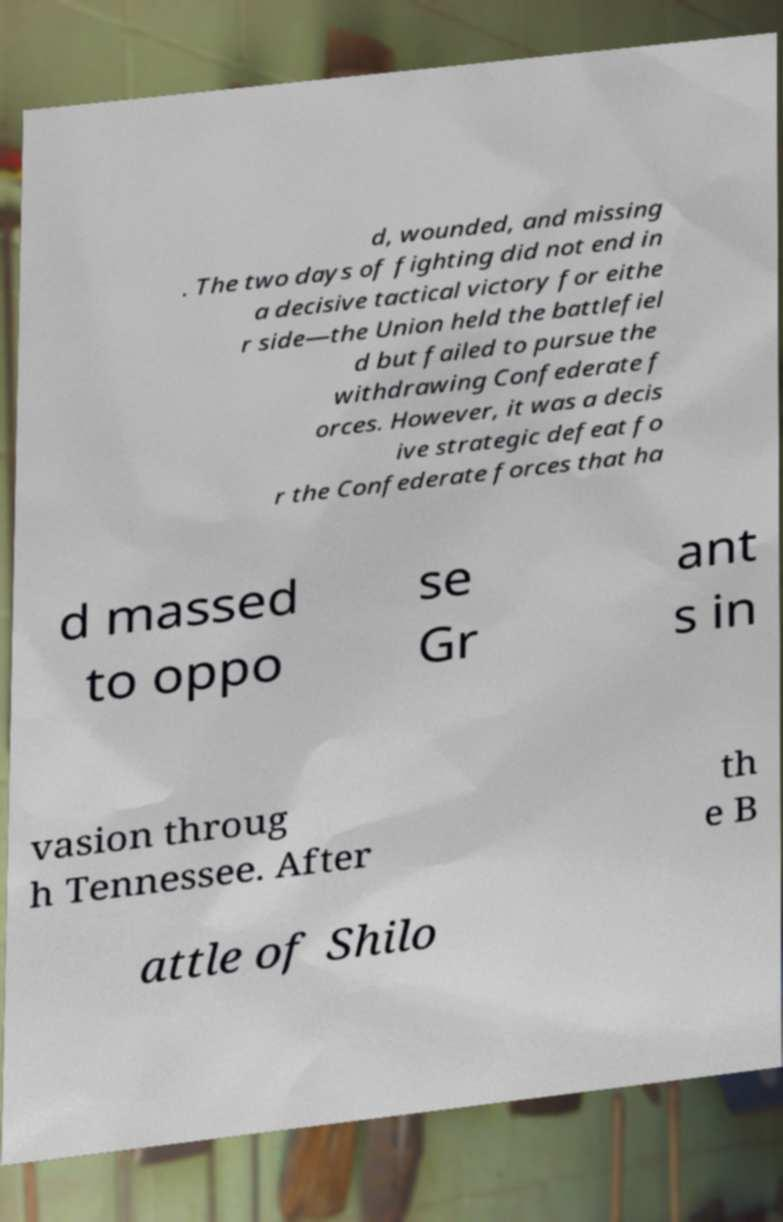Could you extract and type out the text from this image? d, wounded, and missing . The two days of fighting did not end in a decisive tactical victory for eithe r side—the Union held the battlefiel d but failed to pursue the withdrawing Confederate f orces. However, it was a decis ive strategic defeat fo r the Confederate forces that ha d massed to oppo se Gr ant s in vasion throug h Tennessee. After th e B attle of Shilo 